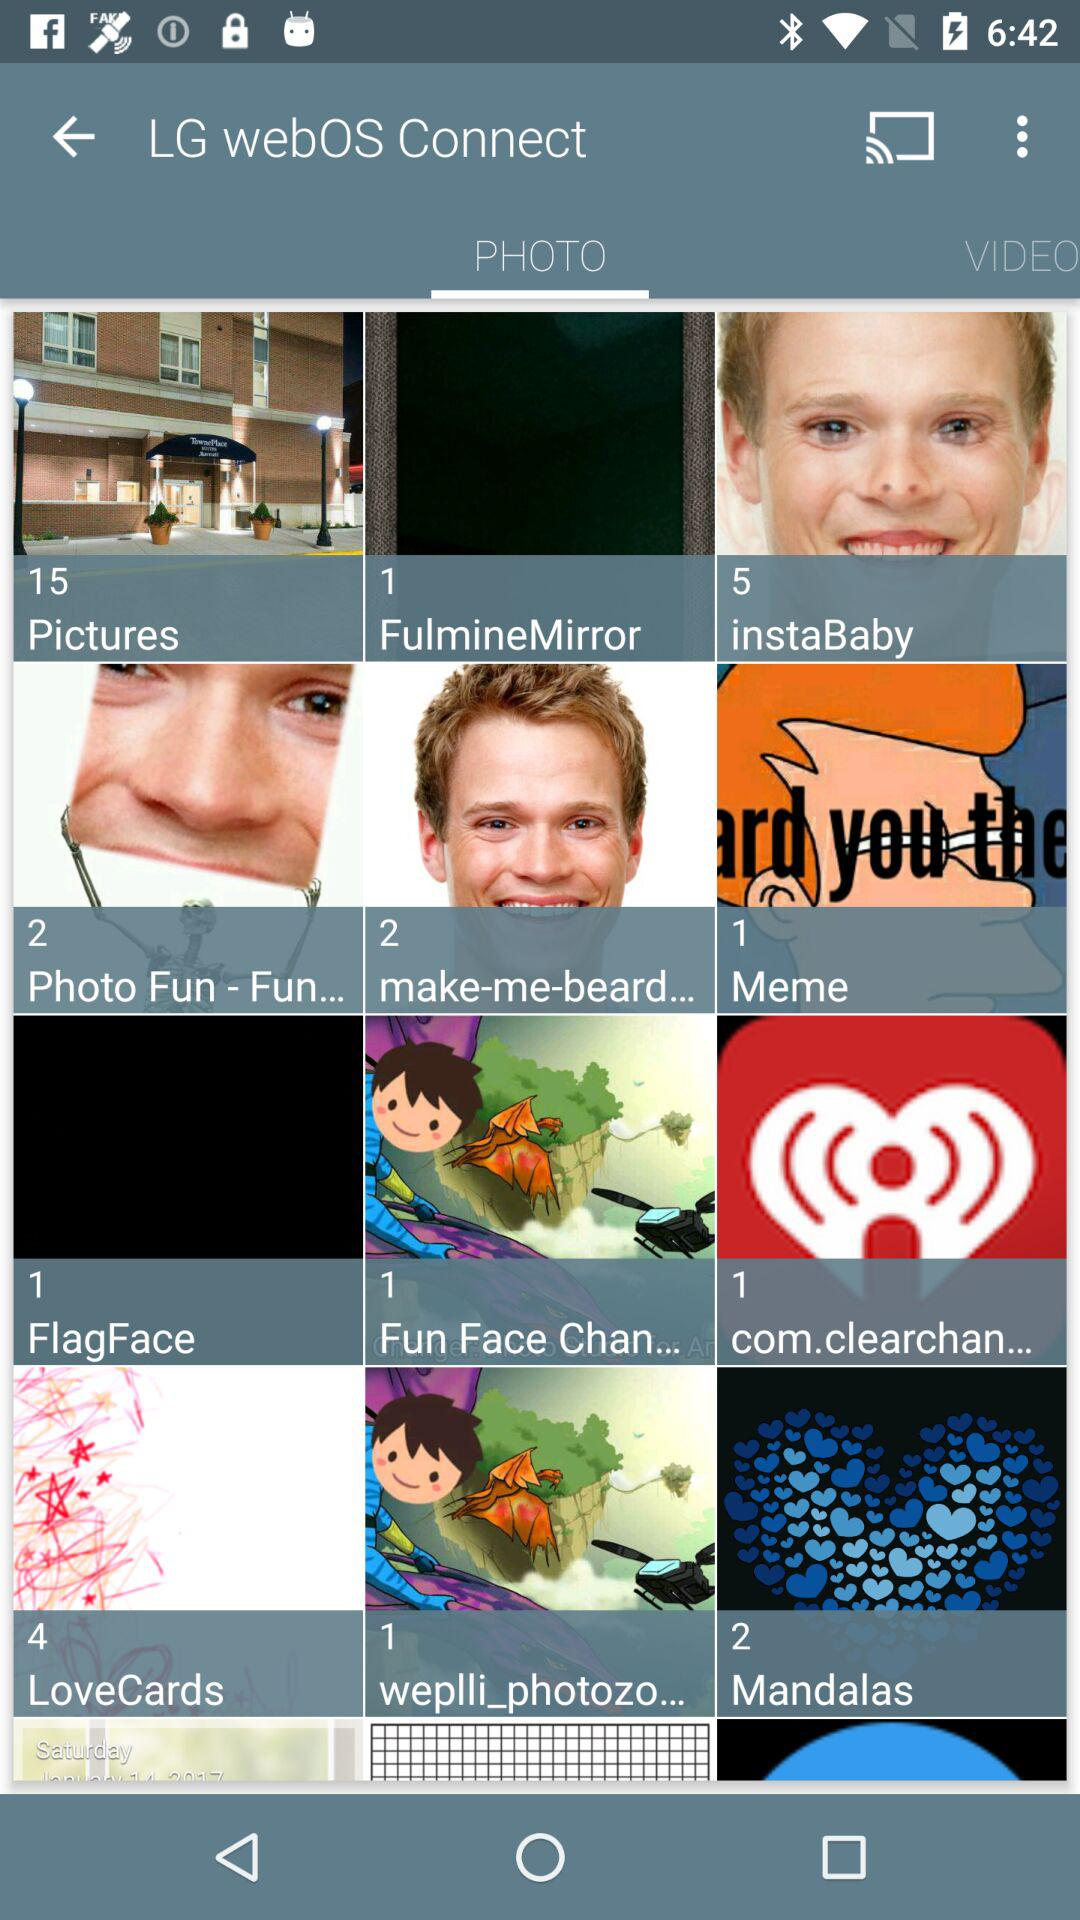How many pictures are in the "instaBaby" folder? There are 5 pictures in the "instaBaby" folder. 